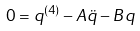Convert formula to latex. <formula><loc_0><loc_0><loc_500><loc_500>0 = q ^ { ( 4 ) } - A \ddot { q } - B q</formula> 